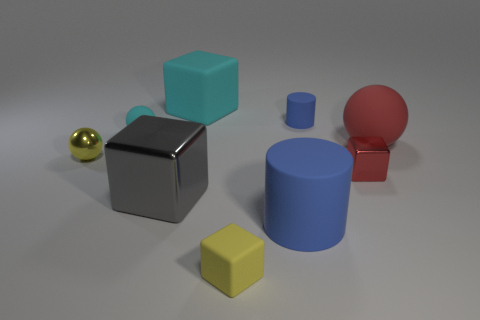Subtract all red cubes. How many cubes are left? 3 Subtract all red blocks. How many blocks are left? 3 Subtract 1 blocks. How many blocks are left? 3 Subtract all red cylinders. Subtract all yellow spheres. How many cylinders are left? 2 Subtract all blue cylinders. How many yellow balls are left? 1 Subtract all cyan matte balls. Subtract all large metallic cubes. How many objects are left? 7 Add 5 cyan things. How many cyan things are left? 7 Add 7 gray spheres. How many gray spheres exist? 7 Subtract 1 cyan cubes. How many objects are left? 8 Subtract all cylinders. How many objects are left? 7 